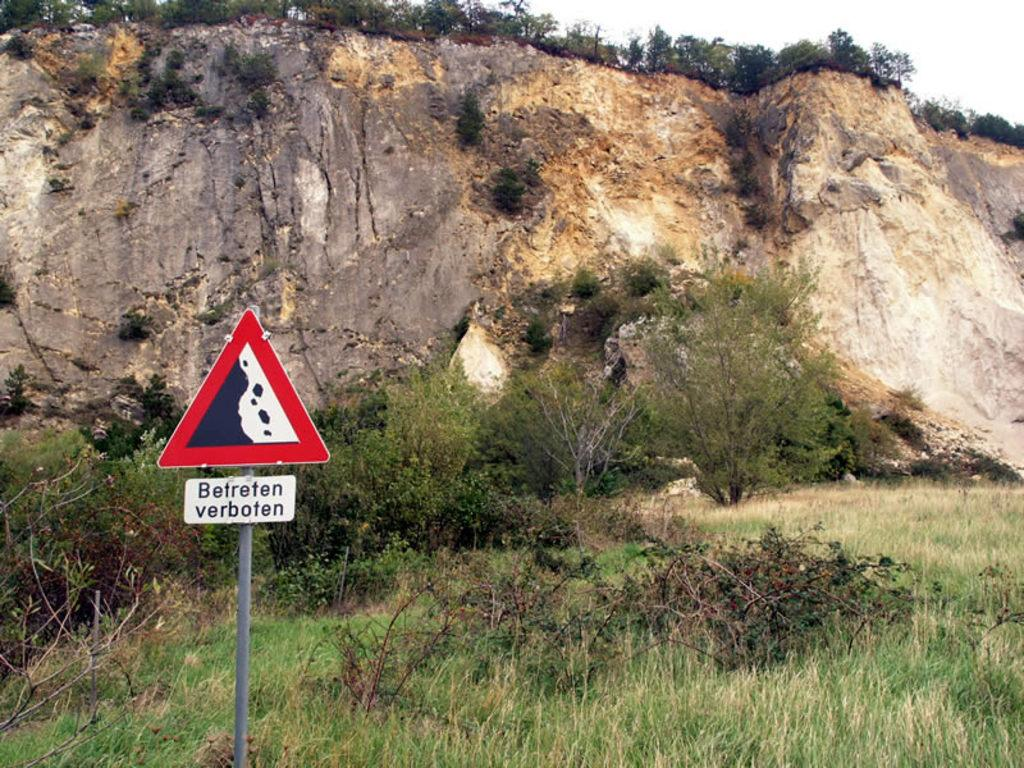Provide a one-sentence caption for the provided image. A sign that says Betreten verboten in front of a cliff. 